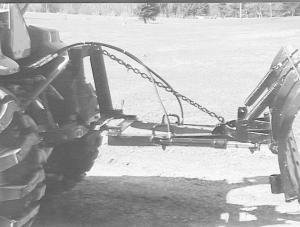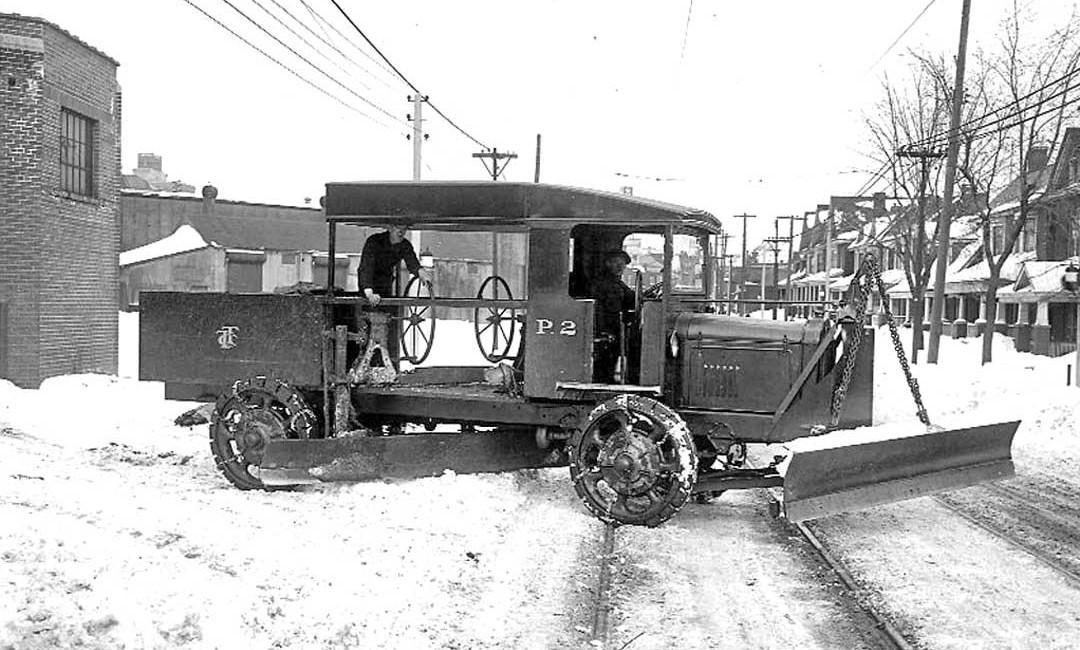The first image is the image on the left, the second image is the image on the right. Considering the images on both sides, is "It is actively snowing in at least one of the images." valid? Answer yes or no. No. 